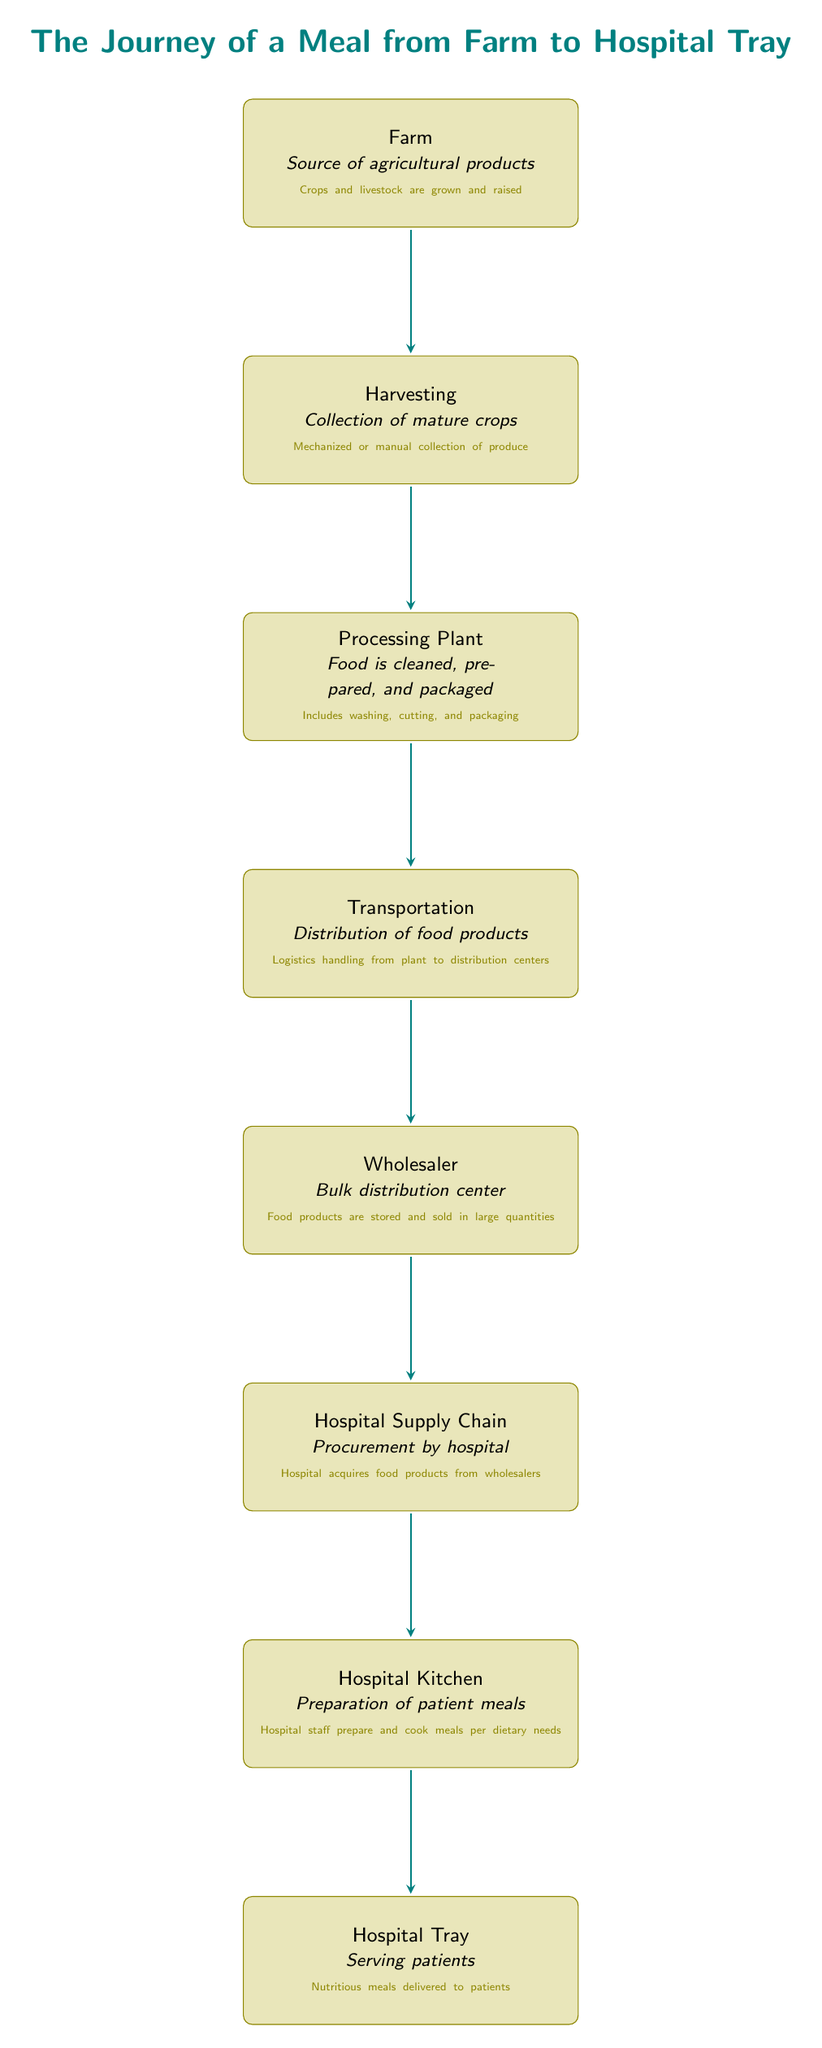What is the first node in the journey of a meal? The first node in the diagram is labeled "Farm," indicating where the journey of a meal begins with agricultural products.
Answer: Farm How many nodes are represented in this diagram? By counting each distinct box in the diagram, we find that there are a total of eight nodes, each representing a step in the meal's journey.
Answer: 8 What process occurs at the second node? The second node is "Harvesting," which involves the collection of mature crops, whether through mechanized or manual collection methods.
Answer: Harvesting Which node follows the processing plant? The node that follows "Processing Plant" is "Transportation," indicating the subsequent step where food products are distributed after processing.
Answer: Transportation What is the final node in the journey of a meal? The last node in the diagram is labeled "Hospital Tray," which signifies the endpoint where nutritious meals are delivered to patients.
Answer: Hospital Tray What is the relationship between the processing plant and the wholesaler? The relationship is one of sequential flow, where food moves from the "Processing Plant" to the "Wholesaler" for storage and bulk distribution.
Answer: Sequential flow What is the purpose of the hospital kitchen in this chain? The hospital kitchen is identified as the node where preparation and cooking of meals occur, tailored to the dietary needs of patients.
Answer: Preparation of patient meals What type of food products are acquired in the hospital supply chain? In the "Hospital Supply Chain" node, food products procured are generally those sourced from wholesalers, indicating bulk and diverse food items.
Answer: Food products from wholesalers What type of products are grown at the farm? The farm grows agricultural products, which include both crops and livestock as indicated in the descriptions within the diagram's first node.
Answer: Crops and livestock 